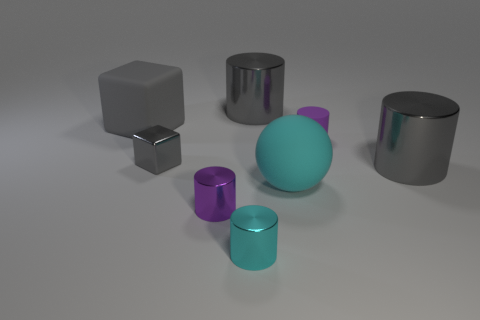What materials are the objects made of that give them varying degrees of shininess? The objects in the image seem to be made of different materials with varying finishes. Some have a reflective, glossy surface suggesting a material like polished metal or plastic, which makes them shiny. Others have a diffuse, non-reflective surface, which could imply a matte material like stone or unpolished metal. 